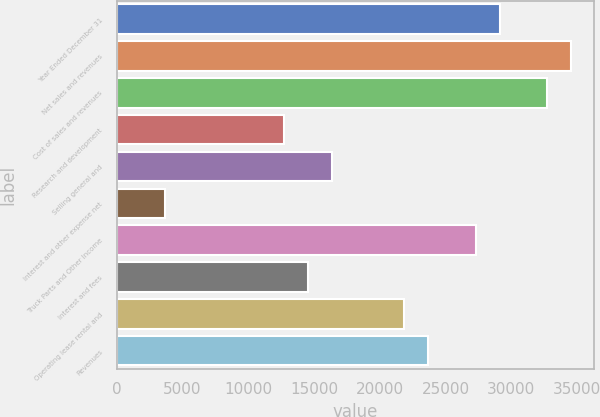Convert chart to OTSL. <chart><loc_0><loc_0><loc_500><loc_500><bar_chart><fcel>Year Ended December 31<fcel>Net sales and revenues<fcel>Cost of sales and revenues<fcel>Research and development<fcel>Selling general and<fcel>Interest and other expense net<fcel>Truck Parts and Other Income<fcel>Interest and fees<fcel>Operating lease rental and<fcel>Revenues<nl><fcel>29097.2<fcel>34552<fcel>32733.7<fcel>12732.7<fcel>16369.2<fcel>3641.31<fcel>27278.9<fcel>14551<fcel>21824.1<fcel>23642.3<nl></chart> 